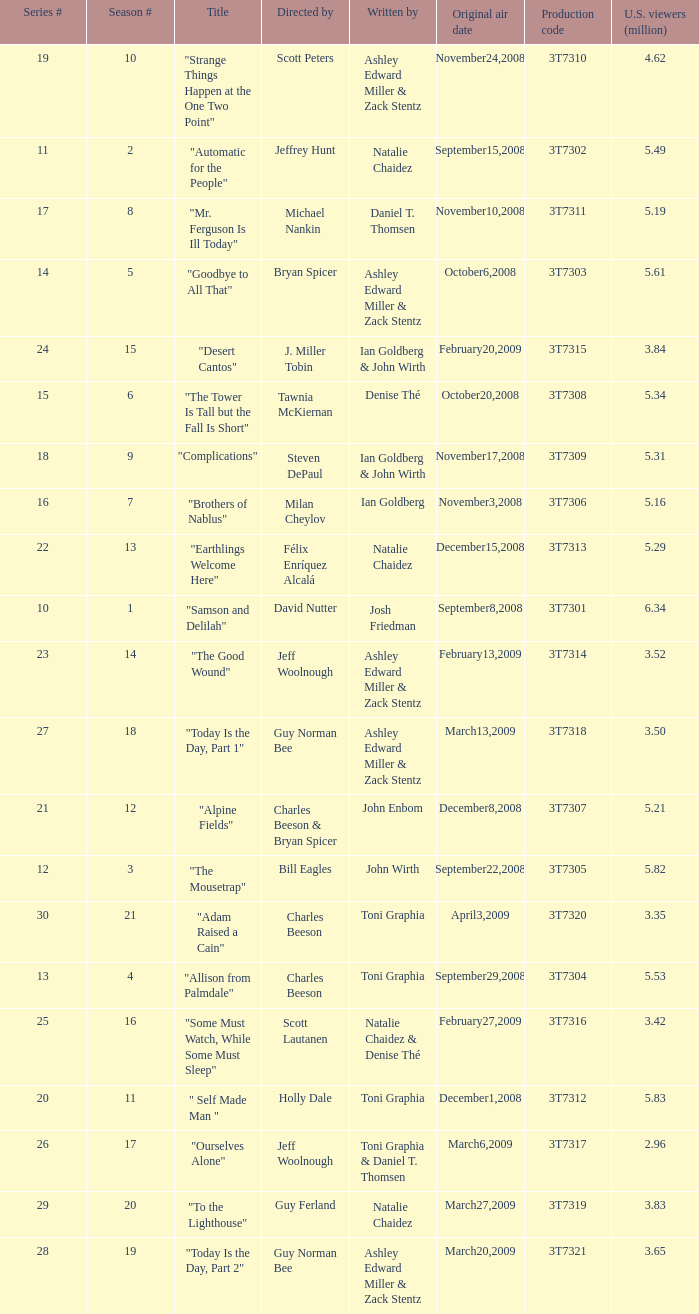Which episode number drew in 3.35 million viewers in the United States? 1.0. 